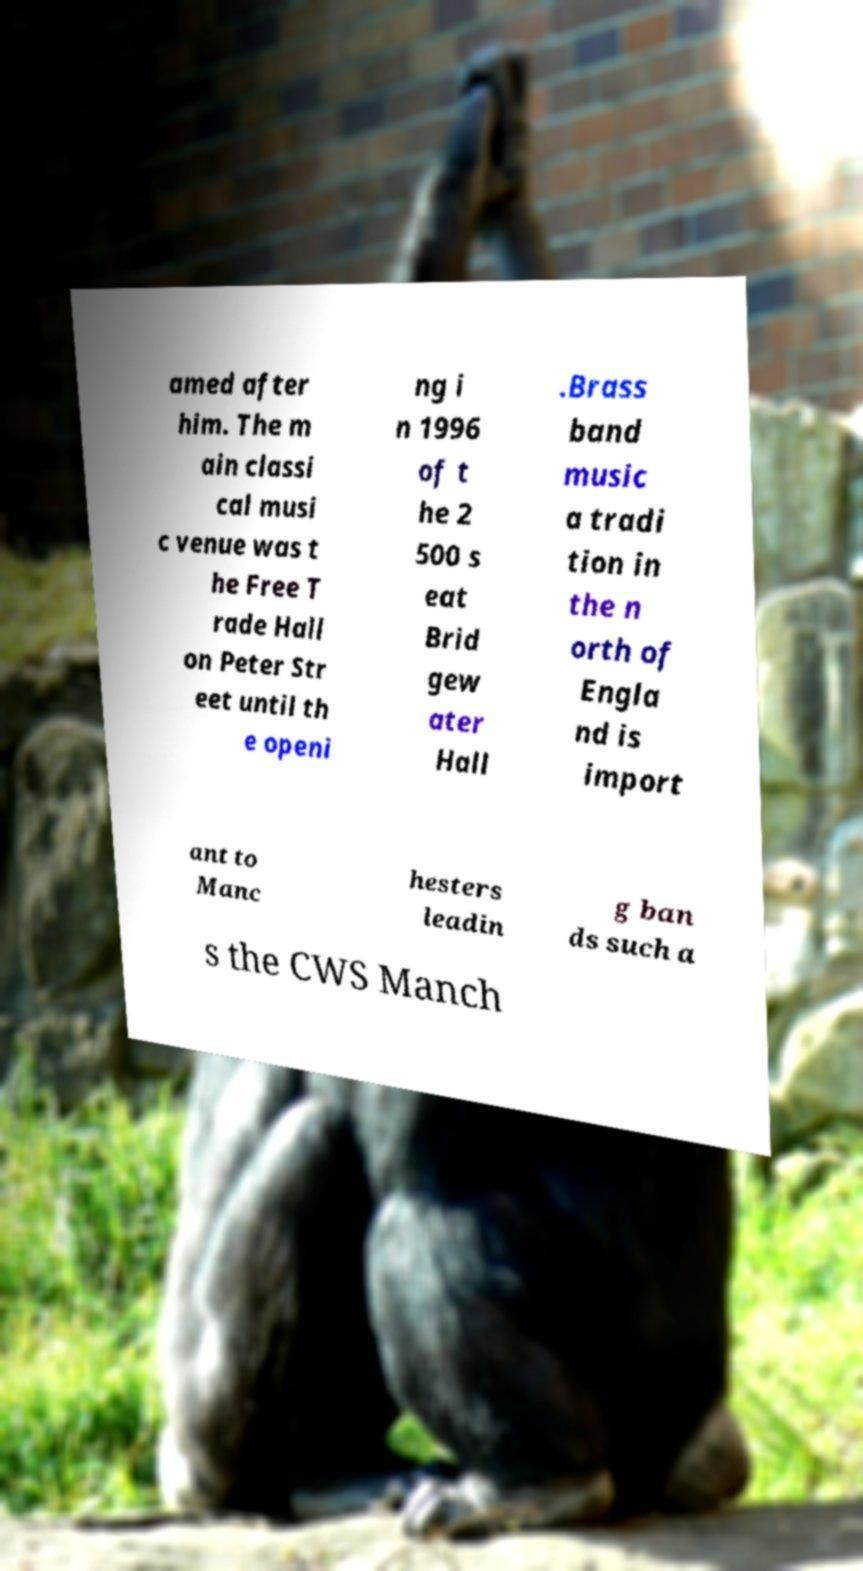What messages or text are displayed in this image? I need them in a readable, typed format. amed after him. The m ain classi cal musi c venue was t he Free T rade Hall on Peter Str eet until th e openi ng i n 1996 of t he 2 500 s eat Brid gew ater Hall .Brass band music a tradi tion in the n orth of Engla nd is import ant to Manc hesters leadin g ban ds such a s the CWS Manch 